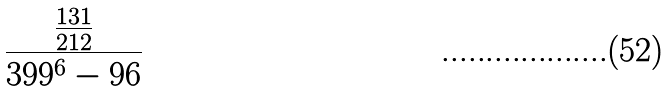<formula> <loc_0><loc_0><loc_500><loc_500>\frac { \frac { 1 3 1 } { 2 1 2 } } { 3 9 9 ^ { 6 } - 9 6 }</formula> 